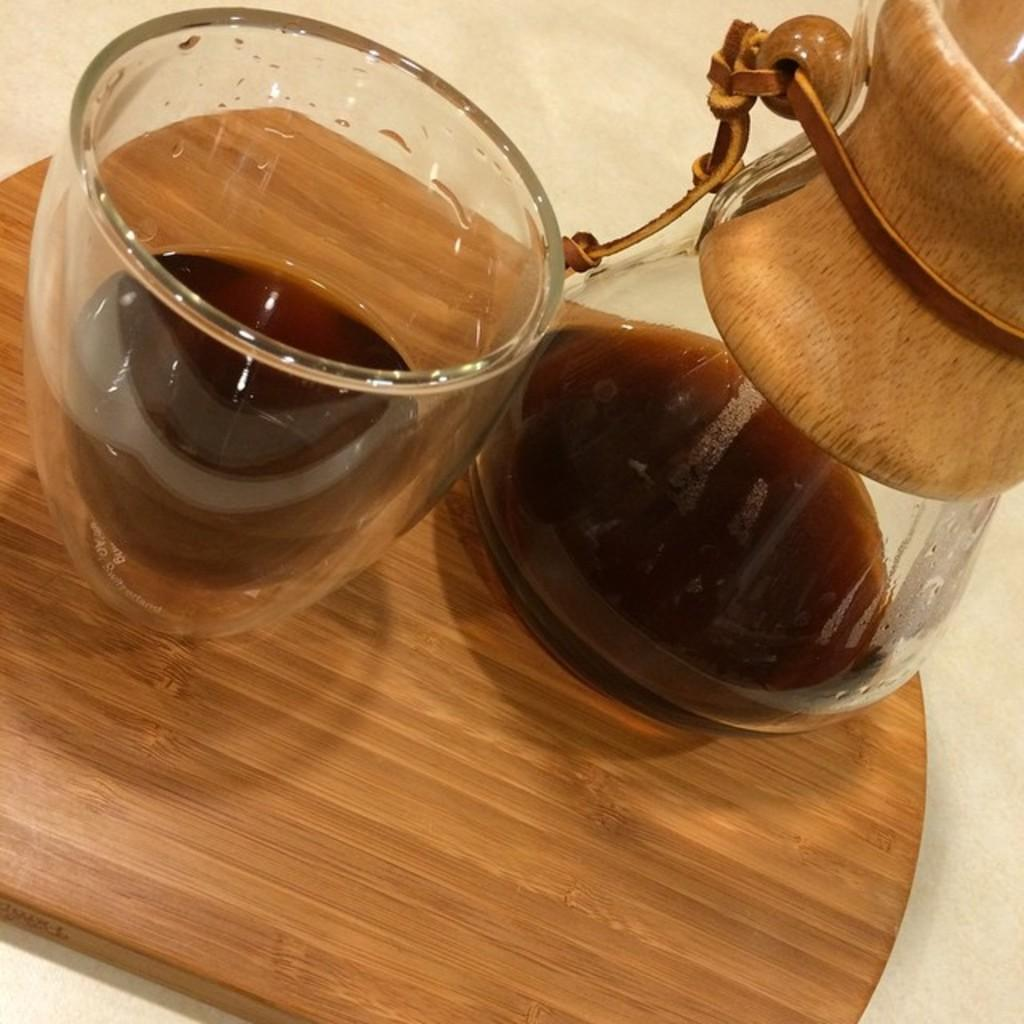What material is at the bottom of the image? There is wood at the bottom of the image. What can be seen on the left side of the image? There is a glass of drink on the left side of the image. What is located on the right side of the image? There is a glass kettle on the right side of the image. What time of day is depicted in the image? The time of day cannot be determined from the image, as there are no clues or indicators of the time. Is there a river visible in the image? No, there is no river present in the image. 